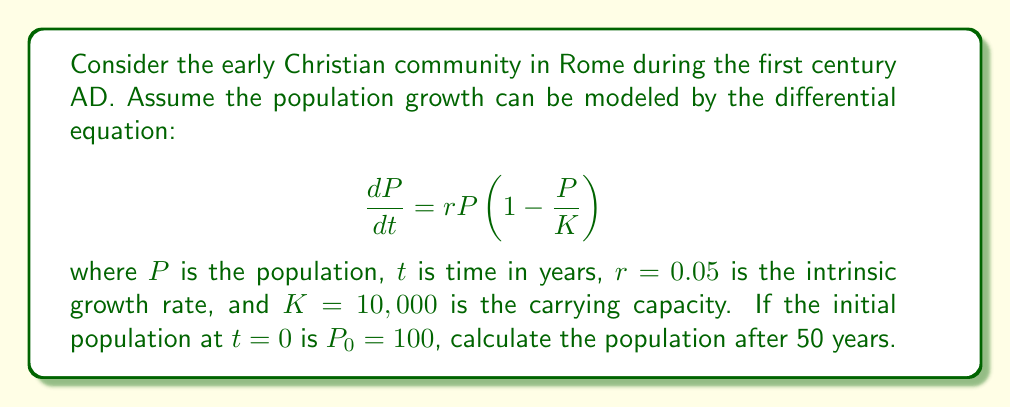Provide a solution to this math problem. To solve this problem, we need to use the logistic growth model, which is described by the given differential equation. This model is appropriate for populations that grow exponentially at first but then slow down as they approach a carrying capacity.

The solution to this differential equation is:

$$P(t) = \frac{KP_0}{P_0 + (K-P_0)e^{-rt}}$$

Where:
- $K = 10,000$ (carrying capacity)
- $P_0 = 100$ (initial population)
- $r = 0.05$ (intrinsic growth rate)
- $t = 50$ (time in years)

Let's substitute these values into the equation:

$$P(50) = \frac{10000 \cdot 100}{100 + (10000-100)e^{-0.05 \cdot 50}}$$

$$= \frac{1,000,000}{100 + 9900e^{-2.5}}$$

$$= \frac{1,000,000}{100 + 9900 \cdot 0.0821}$$

$$= \frac{1,000,000}{100 + 812.79}$$

$$= \frac{1,000,000}{912.79}$$

$$\approx 1095.54$$

Therefore, after 50 years, the population of the early Christian community in Rome would be approximately 1,096 people (rounded to the nearest whole number).
Answer: 1,096 people 